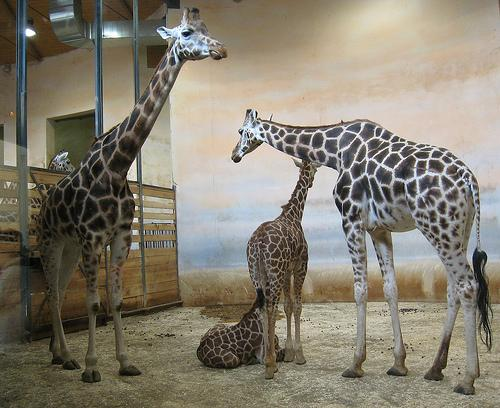Can you identify the primary subject in the image and describe its appearance? The primary subject in the image is a family of giraffes with brown spots, and one of them has black hair on its tail. Count the number of giraffe legs visible in the image and specify if they are front or back legs. There are 14 giraffe legs visible: 4 front legs, 6 back legs, and 4 legs of a giraffe from a nearby enclosure. Mention any artistic details present in the image. There is a mural of a sunset on the wall and a beautiful clean wall within the image, adding an artistic touch to the scene. What are some notable features of the room that the giraffes are in? The room has a silver air duct and a light on the ceiling, a beautiful clean wall, and a hallway door leading out of the room. Analyze the interaction between the objects in the image, focusing on the giraffes. The giraffes seem to be in a peaceful and nurturing environment, with one standing over the two baby giraffes and another lying down. Evaluate the sentiment of the image based on the scene and the animals present. The image has a positive and heartwarming sentiment, showing a family of giraffes together in their enclosure. How many giraffes are in the image and what are they doing? There are four giraffes in the image, some standing, one lying down, and a giraffe standing taller than the others. Describe any stains or contaminants in the image, providing their location and appearance. There is a stain on the floor, a wet area behind the giraffes, and a small dust in the ground within the image. Describe the environment where the giraffes are located. The giraffes are in a wooden enclosure with a mural of a sunset on the wall and a wet area on the floor behind them. Tell me any unusual characteristics of a giraffe in the image. One giraffe has black hair on the end of its tail, and another giraffe has a clovehoof. 